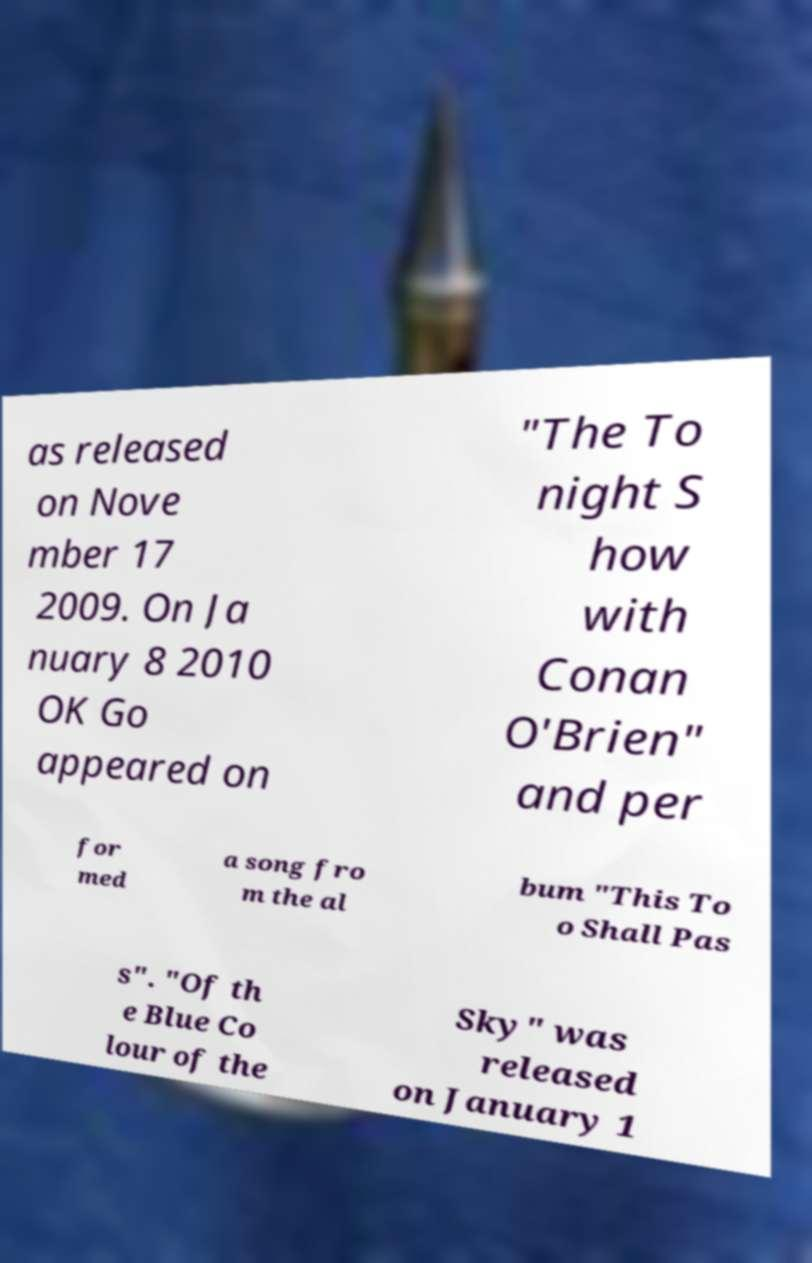Could you assist in decoding the text presented in this image and type it out clearly? as released on Nove mber 17 2009. On Ja nuary 8 2010 OK Go appeared on "The To night S how with Conan O'Brien" and per for med a song fro m the al bum "This To o Shall Pas s". "Of th e Blue Co lour of the Sky" was released on January 1 